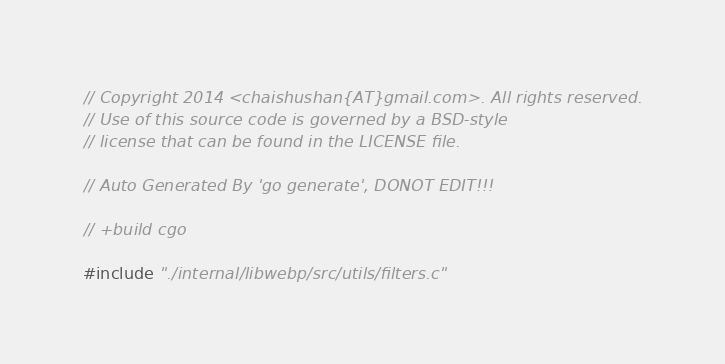<code> <loc_0><loc_0><loc_500><loc_500><_C_>// Copyright 2014 <chaishushan{AT}gmail.com>. All rights reserved.
// Use of this source code is governed by a BSD-style
// license that can be found in the LICENSE file.

// Auto Generated By 'go generate', DONOT EDIT!!!

// +build cgo

#include "./internal/libwebp/src/utils/filters.c"
</code> 